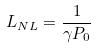Convert formula to latex. <formula><loc_0><loc_0><loc_500><loc_500>L _ { N L } = \frac { 1 } { \gamma P _ { 0 } }</formula> 